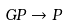Convert formula to latex. <formula><loc_0><loc_0><loc_500><loc_500>G P \rightarrow P</formula> 